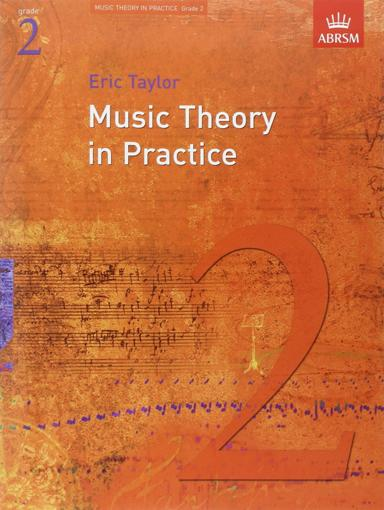Is this book suitable for beginners in music? Yes, "Music Theory in Practice, Grade 2" is designed for beginners who have a basic understanding of music principles. It helps in building foundational skills necessary for further studies in music theory. 